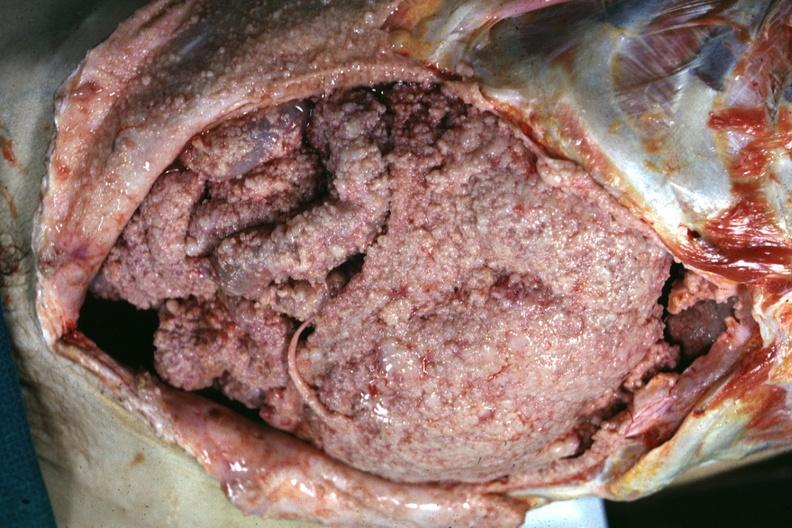where is this area in the body?
Answer the question using a single word or phrase. Abdomen 